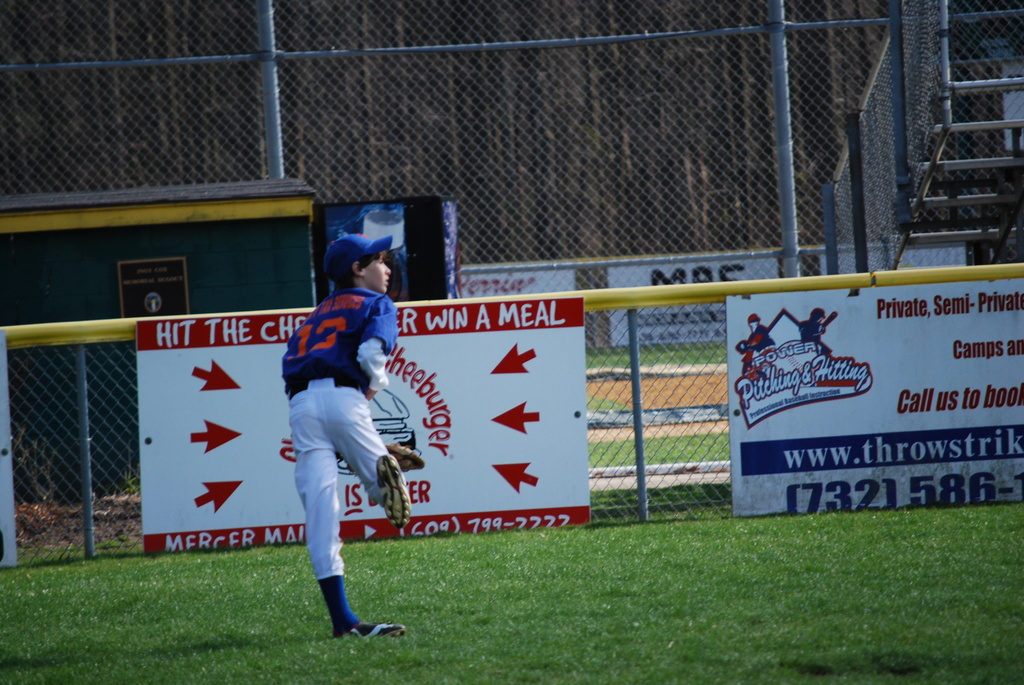What techniques might a baseball coach use to help players improve their catching skills as shown in the image? A coach might focus on drills that enhance players' reaction times and coordination, such as rapid catch exercises, using softer balls to increase confidence in catching without fear of injury, and practicing under different lighting conditions to simulate real game scenarios. 